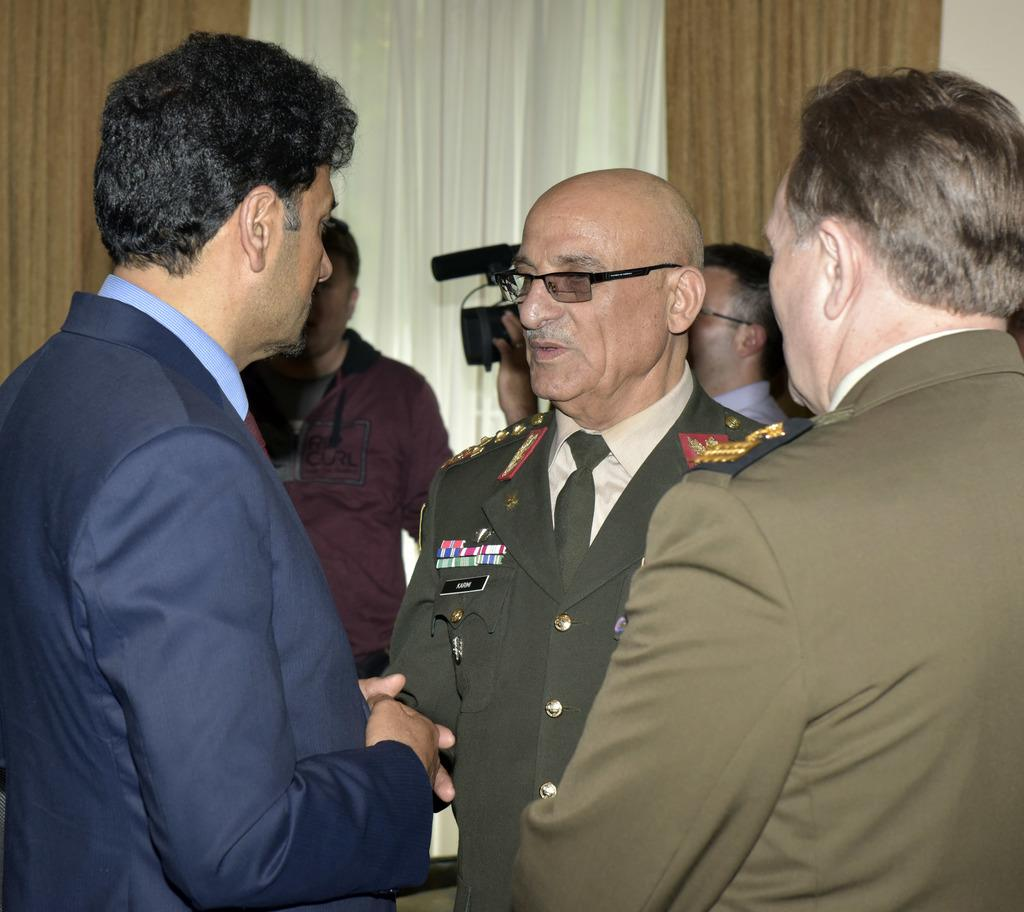How many people are in the image? There are few persons in the image. What is one person doing in the image? One person is holding a camera. What can be seen at the top of the image? There is a white color curtain visible at the top of the image. Can you tell me how many beetles are crawling on the mouth of the person holding the camera? There are no beetles present in the image, and the person holding the camera does not have a mouth visible in the image. 